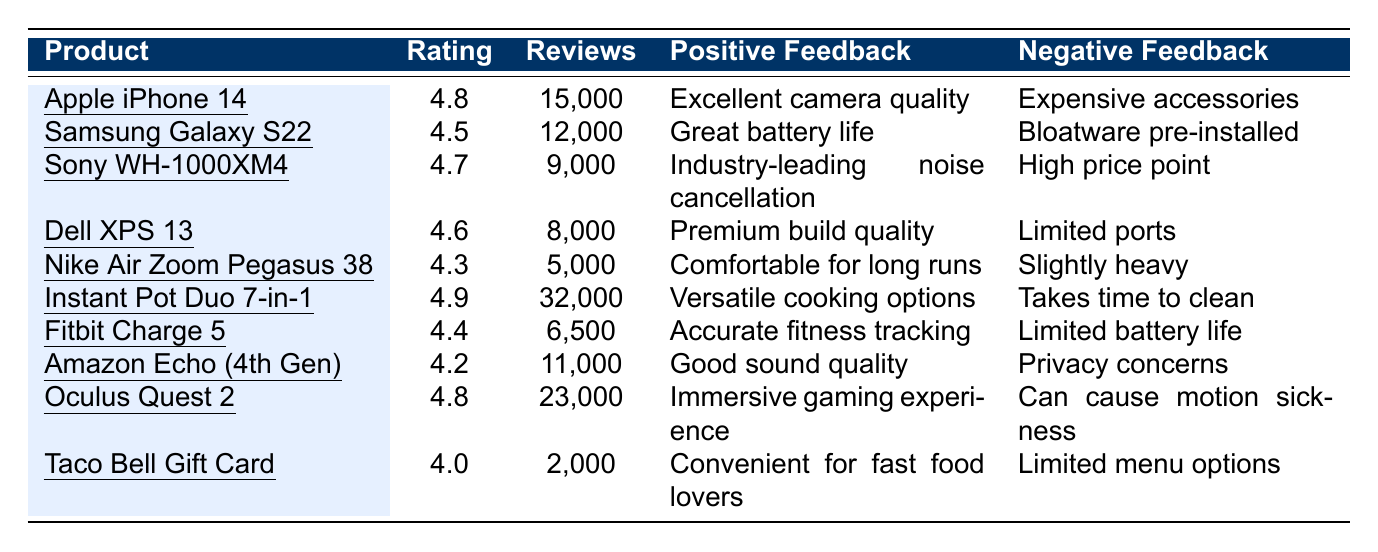What is the highest user rating among the products? The highest user rating in the table is located next to the product "Instant Pot Duo 7-in-1," which has a rating of 4.9.
Answer: 4.9 How many reviews did the "Sony WH-1000XM4" receive? The number of reviews for the "Sony WH-1000XM4" is stated directly in the table, which lists it as 9,000 reviews.
Answer: 9,000 Is the average user rating above 4.5? To find the average, first sum the ratings: (4.8 + 4.5 + 4.7 + 4.6 + 4.3 + 4.9 + 4.4 + 4.2 + 4.8 + 4.0) = 46.2. There are 10 products, so the average is 46.2/10 = 4.62, which is above 4.5.
Answer: Yes What is the difference in user ratings between the "Apple iPhone 14" and "Taco Bell Gift Card"? The rating for the "Apple iPhone 14" is 4.8 and for "Taco Bell Gift Card" is 4.0. The difference is 4.8 - 4.0 = 0.8.
Answer: 0.8 Which product received the most reviews and what is that number? Looking at the review counts, the "Instant Pot Duo 7-in-1" has the highest number of reviews, which is 32,000.
Answer: 32,000 Do any products have the same user rating? By analyzing the ratings, "Apple iPhone 14" and "Oculus Quest 2" both have a rating of 4.8, so yes, they are the same.
Answer: Yes Which product has the largest discrepancy between positive and negative feedback based on the provided feedback? Evaluating feedback, "Instant Pot Duo 7-in-1" has the most positive feedback ("Versatile cooking options") compared to its negative feedback ("Takes time to clean"), indicating a larger gap in perception.
Answer: Instant Pot Duo 7-in-1 What is the median user rating of the products? To find the median, list the ratings in order: 4.0, 4.2, 4.3, 4.4, 4.5, 4.6, 4.7, 4.8, 4.8, 4.9. With 10 products, the median is the average of the 5th and 6th ratings: (4.5 + 4.6)/2 = 4.55.
Answer: 4.55 How many products have a rating below 4.5? The products rated below 4.5 are "Nike Air Zoom Pegasus 38" (4.3), "Fitbit Charge 5" (4.4), and "Amazon Echo (4th Gen)" (4.2), totaling three products.
Answer: 3 Which product has positive feedback focusing on sound quality? The "Amazon Echo (4th Gen)" has positive feedback stating "Good sound quality," indicating this specific focus.
Answer: Amazon Echo (4th Gen) 